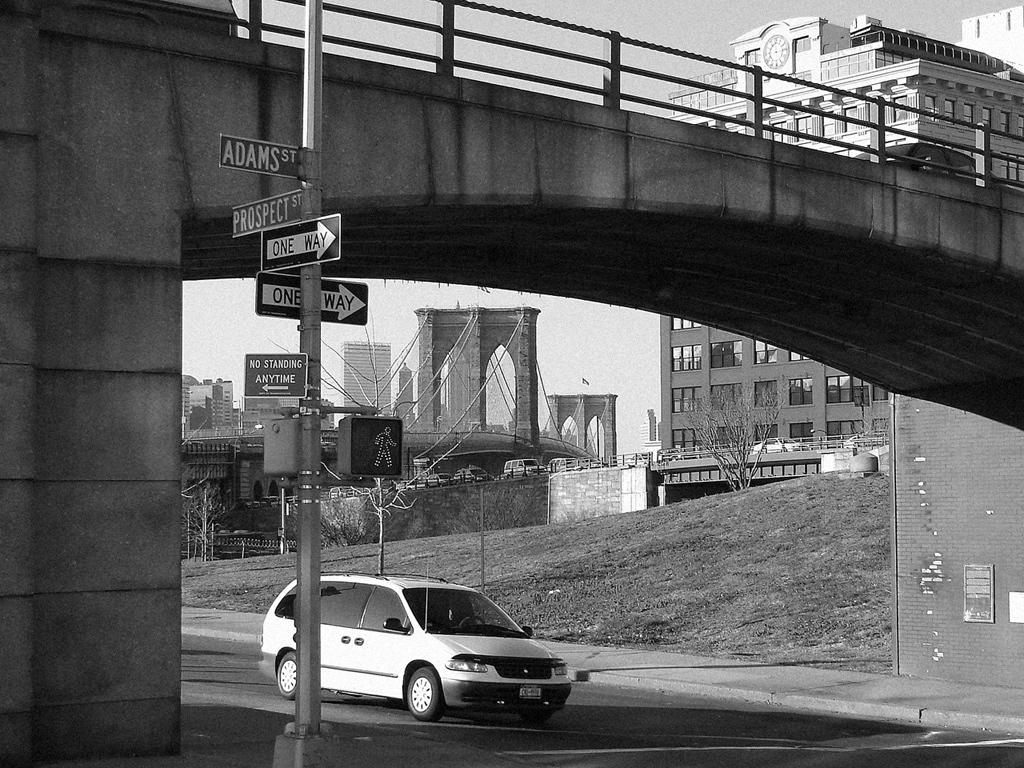<image>
Offer a succinct explanation of the picture presented. A white minivan approaches the intersection of Adams Street and Prospect Street. 